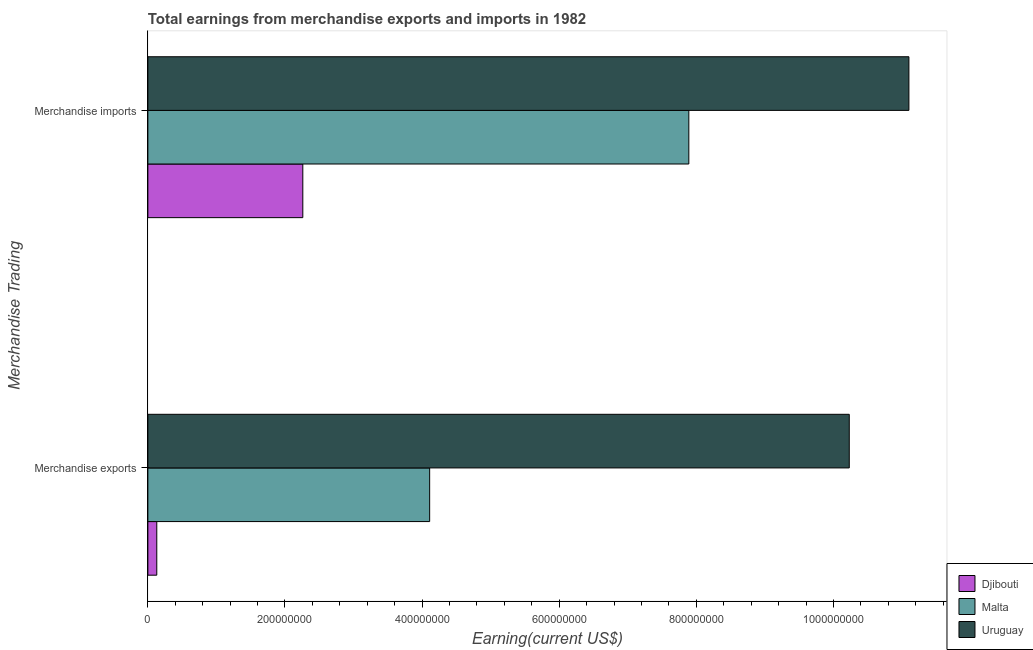How many groups of bars are there?
Keep it short and to the point. 2. Are the number of bars per tick equal to the number of legend labels?
Give a very brief answer. Yes. Are the number of bars on each tick of the Y-axis equal?
Ensure brevity in your answer.  Yes. How many bars are there on the 2nd tick from the top?
Give a very brief answer. 3. How many bars are there on the 2nd tick from the bottom?
Your response must be concise. 3. What is the earnings from merchandise exports in Uruguay?
Make the answer very short. 1.02e+09. Across all countries, what is the maximum earnings from merchandise imports?
Give a very brief answer. 1.11e+09. Across all countries, what is the minimum earnings from merchandise exports?
Give a very brief answer. 1.30e+07. In which country was the earnings from merchandise exports maximum?
Provide a succinct answer. Uruguay. In which country was the earnings from merchandise exports minimum?
Make the answer very short. Djibouti. What is the total earnings from merchandise imports in the graph?
Your answer should be very brief. 2.12e+09. What is the difference between the earnings from merchandise imports in Malta and that in Uruguay?
Provide a succinct answer. -3.21e+08. What is the difference between the earnings from merchandise exports in Uruguay and the earnings from merchandise imports in Malta?
Offer a very short reply. 2.34e+08. What is the average earnings from merchandise imports per country?
Keep it short and to the point. 7.08e+08. What is the difference between the earnings from merchandise imports and earnings from merchandise exports in Uruguay?
Keep it short and to the point. 8.70e+07. What is the ratio of the earnings from merchandise exports in Malta to that in Djibouti?
Your answer should be compact. 31.62. What does the 3rd bar from the top in Merchandise exports represents?
Provide a short and direct response. Djibouti. What does the 2nd bar from the bottom in Merchandise exports represents?
Give a very brief answer. Malta. How many bars are there?
Offer a terse response. 6. Are all the bars in the graph horizontal?
Offer a very short reply. Yes. How many countries are there in the graph?
Keep it short and to the point. 3. What is the difference between two consecutive major ticks on the X-axis?
Provide a succinct answer. 2.00e+08. Are the values on the major ticks of X-axis written in scientific E-notation?
Ensure brevity in your answer.  No. Where does the legend appear in the graph?
Your answer should be very brief. Bottom right. How are the legend labels stacked?
Provide a short and direct response. Vertical. What is the title of the graph?
Offer a very short reply. Total earnings from merchandise exports and imports in 1982. What is the label or title of the X-axis?
Make the answer very short. Earning(current US$). What is the label or title of the Y-axis?
Your answer should be compact. Merchandise Trading. What is the Earning(current US$) of Djibouti in Merchandise exports?
Keep it short and to the point. 1.30e+07. What is the Earning(current US$) in Malta in Merchandise exports?
Provide a succinct answer. 4.11e+08. What is the Earning(current US$) of Uruguay in Merchandise exports?
Offer a terse response. 1.02e+09. What is the Earning(current US$) in Djibouti in Merchandise imports?
Your answer should be very brief. 2.26e+08. What is the Earning(current US$) in Malta in Merchandise imports?
Your answer should be compact. 7.89e+08. What is the Earning(current US$) in Uruguay in Merchandise imports?
Provide a succinct answer. 1.11e+09. Across all Merchandise Trading, what is the maximum Earning(current US$) of Djibouti?
Make the answer very short. 2.26e+08. Across all Merchandise Trading, what is the maximum Earning(current US$) in Malta?
Your answer should be very brief. 7.89e+08. Across all Merchandise Trading, what is the maximum Earning(current US$) of Uruguay?
Give a very brief answer. 1.11e+09. Across all Merchandise Trading, what is the minimum Earning(current US$) of Djibouti?
Keep it short and to the point. 1.30e+07. Across all Merchandise Trading, what is the minimum Earning(current US$) in Malta?
Your answer should be very brief. 4.11e+08. Across all Merchandise Trading, what is the minimum Earning(current US$) in Uruguay?
Your answer should be compact. 1.02e+09. What is the total Earning(current US$) in Djibouti in the graph?
Ensure brevity in your answer.  2.39e+08. What is the total Earning(current US$) of Malta in the graph?
Provide a succinct answer. 1.20e+09. What is the total Earning(current US$) of Uruguay in the graph?
Your response must be concise. 2.13e+09. What is the difference between the Earning(current US$) in Djibouti in Merchandise exports and that in Merchandise imports?
Your answer should be very brief. -2.13e+08. What is the difference between the Earning(current US$) in Malta in Merchandise exports and that in Merchandise imports?
Your response must be concise. -3.78e+08. What is the difference between the Earning(current US$) of Uruguay in Merchandise exports and that in Merchandise imports?
Your answer should be very brief. -8.70e+07. What is the difference between the Earning(current US$) in Djibouti in Merchandise exports and the Earning(current US$) in Malta in Merchandise imports?
Keep it short and to the point. -7.76e+08. What is the difference between the Earning(current US$) in Djibouti in Merchandise exports and the Earning(current US$) in Uruguay in Merchandise imports?
Keep it short and to the point. -1.10e+09. What is the difference between the Earning(current US$) of Malta in Merchandise exports and the Earning(current US$) of Uruguay in Merchandise imports?
Your response must be concise. -6.99e+08. What is the average Earning(current US$) of Djibouti per Merchandise Trading?
Provide a succinct answer. 1.20e+08. What is the average Earning(current US$) in Malta per Merchandise Trading?
Provide a short and direct response. 6.00e+08. What is the average Earning(current US$) of Uruguay per Merchandise Trading?
Offer a terse response. 1.07e+09. What is the difference between the Earning(current US$) of Djibouti and Earning(current US$) of Malta in Merchandise exports?
Offer a terse response. -3.98e+08. What is the difference between the Earning(current US$) of Djibouti and Earning(current US$) of Uruguay in Merchandise exports?
Your answer should be compact. -1.01e+09. What is the difference between the Earning(current US$) of Malta and Earning(current US$) of Uruguay in Merchandise exports?
Make the answer very short. -6.12e+08. What is the difference between the Earning(current US$) in Djibouti and Earning(current US$) in Malta in Merchandise imports?
Give a very brief answer. -5.63e+08. What is the difference between the Earning(current US$) of Djibouti and Earning(current US$) of Uruguay in Merchandise imports?
Ensure brevity in your answer.  -8.84e+08. What is the difference between the Earning(current US$) of Malta and Earning(current US$) of Uruguay in Merchandise imports?
Offer a terse response. -3.21e+08. What is the ratio of the Earning(current US$) in Djibouti in Merchandise exports to that in Merchandise imports?
Keep it short and to the point. 0.06. What is the ratio of the Earning(current US$) of Malta in Merchandise exports to that in Merchandise imports?
Ensure brevity in your answer.  0.52. What is the ratio of the Earning(current US$) in Uruguay in Merchandise exports to that in Merchandise imports?
Provide a succinct answer. 0.92. What is the difference between the highest and the second highest Earning(current US$) in Djibouti?
Provide a short and direct response. 2.13e+08. What is the difference between the highest and the second highest Earning(current US$) of Malta?
Give a very brief answer. 3.78e+08. What is the difference between the highest and the second highest Earning(current US$) in Uruguay?
Give a very brief answer. 8.70e+07. What is the difference between the highest and the lowest Earning(current US$) in Djibouti?
Your answer should be very brief. 2.13e+08. What is the difference between the highest and the lowest Earning(current US$) in Malta?
Offer a very short reply. 3.78e+08. What is the difference between the highest and the lowest Earning(current US$) in Uruguay?
Your answer should be compact. 8.70e+07. 